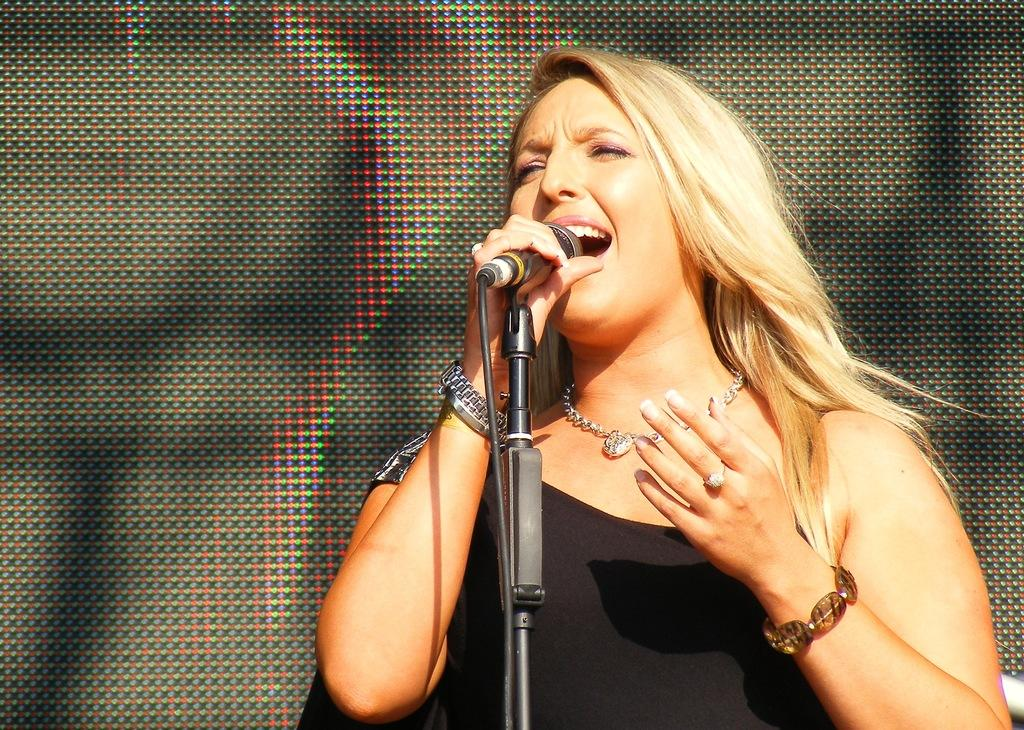Who is the main subject in the image? There is a woman in the image. What is the woman doing in the image? The woman is singing. What tool is the woman using while singing? The woman is using a microphone. What direction is the son facing in the image? There is no son present in the image; it only features a woman singing with a microphone. 